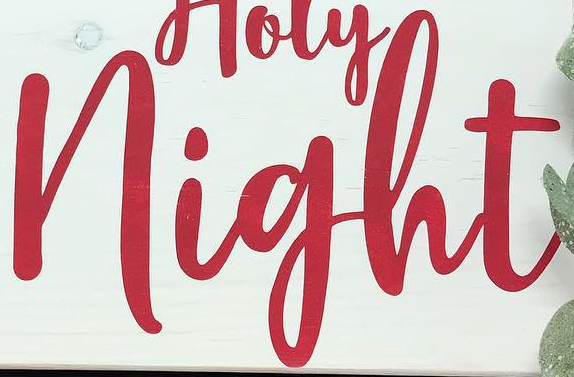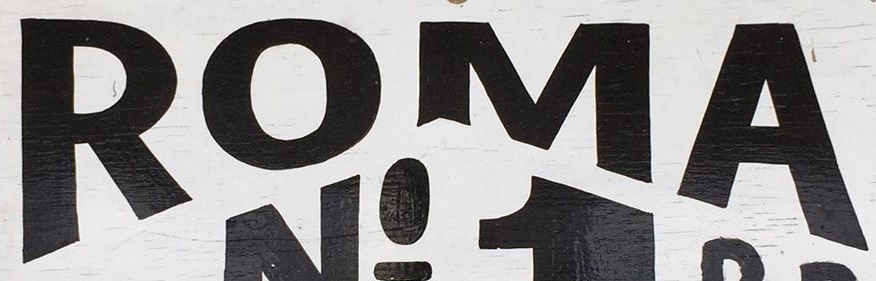What words are shown in these images in order, separated by a semicolon? night; ROMA 